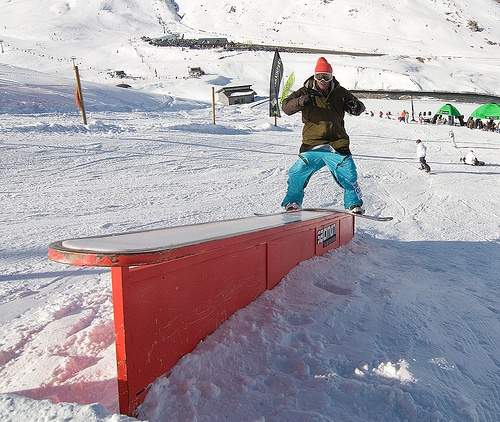Describe the objects in this image and their specific colors. I can see people in white, black, gray, and teal tones, snowboard in white, darkgray, gray, brown, and lightgray tones, people in white, gray, darkgray, and black tones, people in white, darkgray, and gray tones, and people in white, black, gray, and beige tones in this image. 